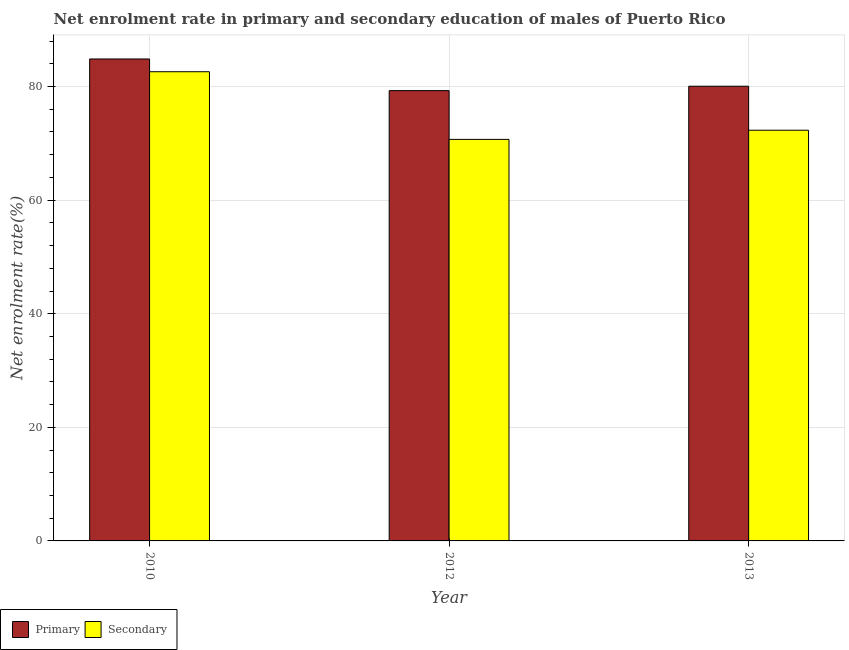How many different coloured bars are there?
Provide a succinct answer. 2. How many groups of bars are there?
Ensure brevity in your answer.  3. Are the number of bars per tick equal to the number of legend labels?
Ensure brevity in your answer.  Yes. Are the number of bars on each tick of the X-axis equal?
Offer a terse response. Yes. How many bars are there on the 3rd tick from the left?
Make the answer very short. 2. In how many cases, is the number of bars for a given year not equal to the number of legend labels?
Provide a succinct answer. 0. What is the enrollment rate in primary education in 2012?
Your answer should be compact. 79.28. Across all years, what is the maximum enrollment rate in primary education?
Ensure brevity in your answer.  84.85. Across all years, what is the minimum enrollment rate in primary education?
Your response must be concise. 79.28. In which year was the enrollment rate in secondary education minimum?
Offer a terse response. 2012. What is the total enrollment rate in primary education in the graph?
Your response must be concise. 244.18. What is the difference between the enrollment rate in secondary education in 2012 and that in 2013?
Make the answer very short. -1.61. What is the difference between the enrollment rate in secondary education in 2010 and the enrollment rate in primary education in 2013?
Offer a very short reply. 10.3. What is the average enrollment rate in primary education per year?
Ensure brevity in your answer.  81.39. What is the ratio of the enrollment rate in primary education in 2010 to that in 2013?
Keep it short and to the point. 1.06. Is the enrollment rate in secondary education in 2012 less than that in 2013?
Make the answer very short. Yes. What is the difference between the highest and the second highest enrollment rate in primary education?
Keep it short and to the point. 4.8. What is the difference between the highest and the lowest enrollment rate in primary education?
Provide a succinct answer. 5.57. Is the sum of the enrollment rate in primary education in 2010 and 2013 greater than the maximum enrollment rate in secondary education across all years?
Your answer should be compact. Yes. What does the 1st bar from the left in 2012 represents?
Your answer should be very brief. Primary. What does the 2nd bar from the right in 2013 represents?
Give a very brief answer. Primary. Are all the bars in the graph horizontal?
Your answer should be compact. No. What is the difference between two consecutive major ticks on the Y-axis?
Offer a very short reply. 20. Are the values on the major ticks of Y-axis written in scientific E-notation?
Keep it short and to the point. No. What is the title of the graph?
Ensure brevity in your answer.  Net enrolment rate in primary and secondary education of males of Puerto Rico. Does "Investments" appear as one of the legend labels in the graph?
Ensure brevity in your answer.  No. What is the label or title of the X-axis?
Offer a very short reply. Year. What is the label or title of the Y-axis?
Keep it short and to the point. Net enrolment rate(%). What is the Net enrolment rate(%) of Primary in 2010?
Offer a terse response. 84.85. What is the Net enrolment rate(%) of Secondary in 2010?
Offer a terse response. 82.6. What is the Net enrolment rate(%) of Primary in 2012?
Provide a succinct answer. 79.28. What is the Net enrolment rate(%) of Secondary in 2012?
Your answer should be compact. 70.69. What is the Net enrolment rate(%) of Primary in 2013?
Offer a very short reply. 80.05. What is the Net enrolment rate(%) of Secondary in 2013?
Keep it short and to the point. 72.31. Across all years, what is the maximum Net enrolment rate(%) in Primary?
Offer a very short reply. 84.85. Across all years, what is the maximum Net enrolment rate(%) of Secondary?
Offer a very short reply. 82.6. Across all years, what is the minimum Net enrolment rate(%) in Primary?
Provide a succinct answer. 79.28. Across all years, what is the minimum Net enrolment rate(%) in Secondary?
Keep it short and to the point. 70.69. What is the total Net enrolment rate(%) in Primary in the graph?
Keep it short and to the point. 244.18. What is the total Net enrolment rate(%) in Secondary in the graph?
Your answer should be compact. 225.6. What is the difference between the Net enrolment rate(%) of Primary in 2010 and that in 2012?
Give a very brief answer. 5.57. What is the difference between the Net enrolment rate(%) of Secondary in 2010 and that in 2012?
Ensure brevity in your answer.  11.91. What is the difference between the Net enrolment rate(%) of Primary in 2010 and that in 2013?
Give a very brief answer. 4.8. What is the difference between the Net enrolment rate(%) of Secondary in 2010 and that in 2013?
Offer a very short reply. 10.3. What is the difference between the Net enrolment rate(%) of Primary in 2012 and that in 2013?
Give a very brief answer. -0.77. What is the difference between the Net enrolment rate(%) of Secondary in 2012 and that in 2013?
Provide a short and direct response. -1.61. What is the difference between the Net enrolment rate(%) of Primary in 2010 and the Net enrolment rate(%) of Secondary in 2012?
Give a very brief answer. 14.16. What is the difference between the Net enrolment rate(%) of Primary in 2010 and the Net enrolment rate(%) of Secondary in 2013?
Provide a succinct answer. 12.55. What is the difference between the Net enrolment rate(%) in Primary in 2012 and the Net enrolment rate(%) in Secondary in 2013?
Offer a very short reply. 6.97. What is the average Net enrolment rate(%) in Primary per year?
Give a very brief answer. 81.39. What is the average Net enrolment rate(%) of Secondary per year?
Offer a very short reply. 75.2. In the year 2010, what is the difference between the Net enrolment rate(%) in Primary and Net enrolment rate(%) in Secondary?
Provide a succinct answer. 2.25. In the year 2012, what is the difference between the Net enrolment rate(%) in Primary and Net enrolment rate(%) in Secondary?
Provide a succinct answer. 8.59. In the year 2013, what is the difference between the Net enrolment rate(%) in Primary and Net enrolment rate(%) in Secondary?
Give a very brief answer. 7.75. What is the ratio of the Net enrolment rate(%) in Primary in 2010 to that in 2012?
Ensure brevity in your answer.  1.07. What is the ratio of the Net enrolment rate(%) in Secondary in 2010 to that in 2012?
Provide a succinct answer. 1.17. What is the ratio of the Net enrolment rate(%) in Primary in 2010 to that in 2013?
Give a very brief answer. 1.06. What is the ratio of the Net enrolment rate(%) of Secondary in 2010 to that in 2013?
Ensure brevity in your answer.  1.14. What is the ratio of the Net enrolment rate(%) of Primary in 2012 to that in 2013?
Your response must be concise. 0.99. What is the ratio of the Net enrolment rate(%) of Secondary in 2012 to that in 2013?
Ensure brevity in your answer.  0.98. What is the difference between the highest and the second highest Net enrolment rate(%) in Primary?
Offer a very short reply. 4.8. What is the difference between the highest and the second highest Net enrolment rate(%) in Secondary?
Your answer should be compact. 10.3. What is the difference between the highest and the lowest Net enrolment rate(%) of Primary?
Your response must be concise. 5.57. What is the difference between the highest and the lowest Net enrolment rate(%) of Secondary?
Offer a terse response. 11.91. 